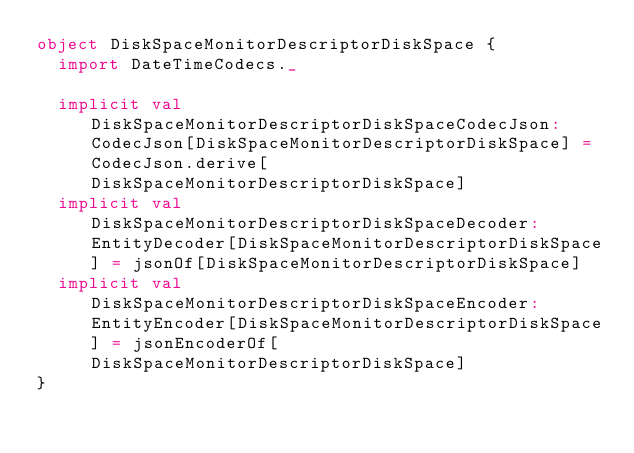Convert code to text. <code><loc_0><loc_0><loc_500><loc_500><_Scala_>object DiskSpaceMonitorDescriptorDiskSpace {
  import DateTimeCodecs._

  implicit val DiskSpaceMonitorDescriptorDiskSpaceCodecJson: CodecJson[DiskSpaceMonitorDescriptorDiskSpace] = CodecJson.derive[DiskSpaceMonitorDescriptorDiskSpace]
  implicit val DiskSpaceMonitorDescriptorDiskSpaceDecoder: EntityDecoder[DiskSpaceMonitorDescriptorDiskSpace] = jsonOf[DiskSpaceMonitorDescriptorDiskSpace]
  implicit val DiskSpaceMonitorDescriptorDiskSpaceEncoder: EntityEncoder[DiskSpaceMonitorDescriptorDiskSpace] = jsonEncoderOf[DiskSpaceMonitorDescriptorDiskSpace]
}
</code> 